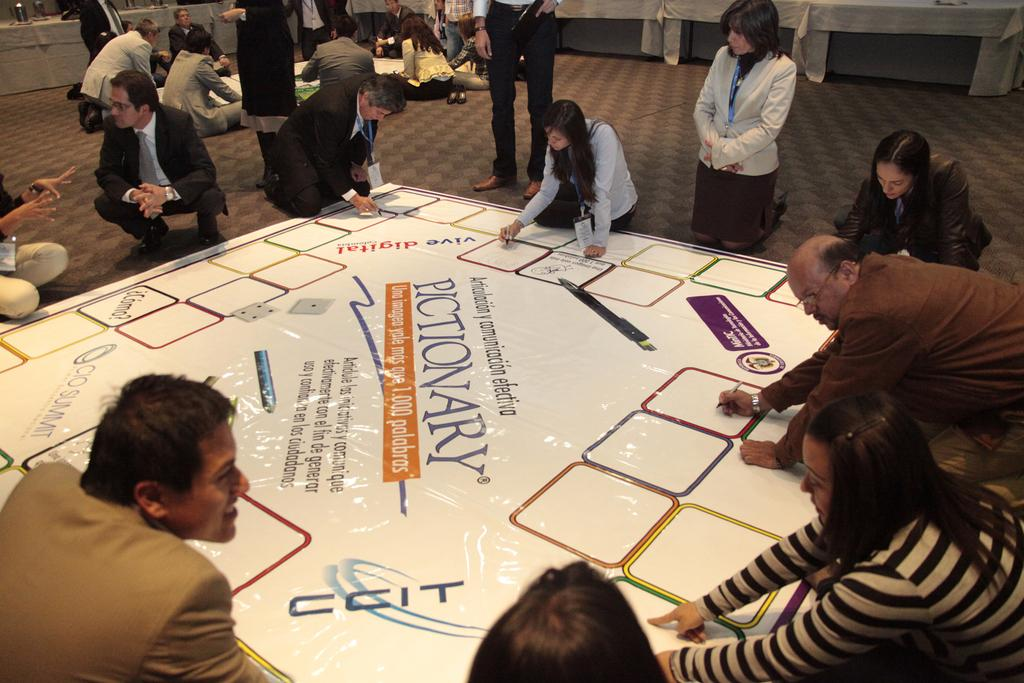What are the people in the image doing around the poster? There are people sitting around a poster in the image, and some of them are writing. Can you describe the second poster visible in the image? There is another poster visible in the background, but its content is not mentioned in the facts. Are there any other people in the image besides those around the first poster? Yes, there are people near the second poster in the background. What type of sweater is the person wearing in the cave in the image? There is no mention of a cave or a person wearing a sweater in the image. What color are the clouds in the sky in the image? There is no mention of clouds or a sky in the image. 